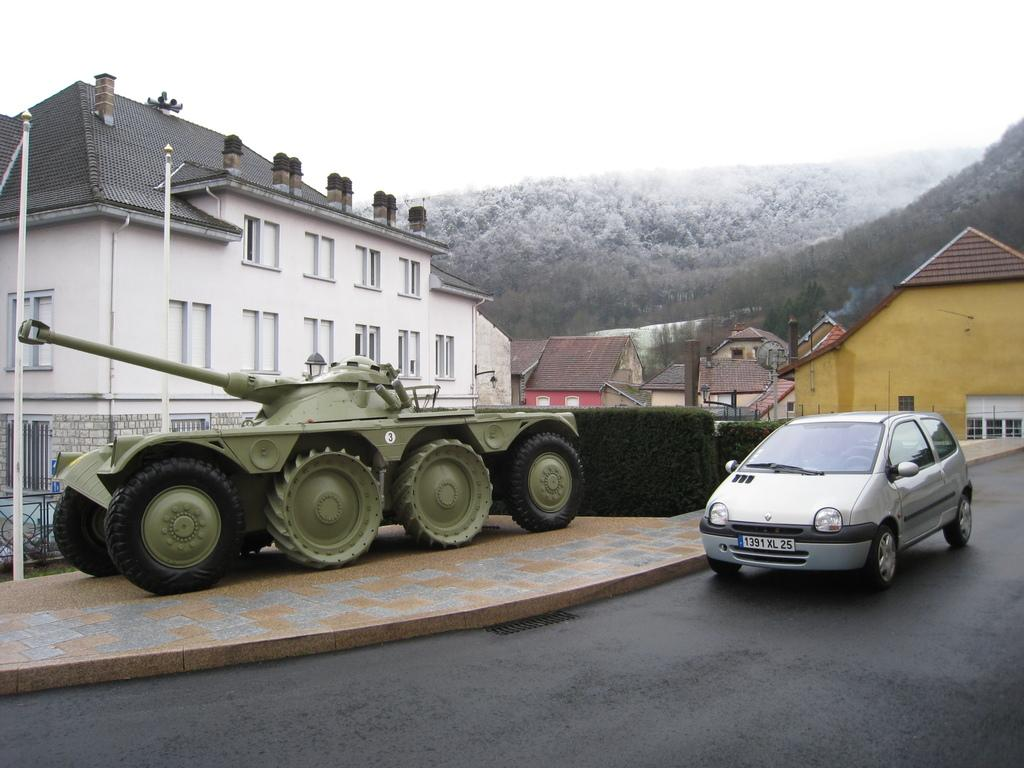What type of vehicle is in the image? There is an armored car in the image. What can be seen in the background of the image? There are buildings, hills, sheds, a hedge, and the sky visible in the background of the image. What is at the bottom of the image? There is a road at the bottom of the image. How many dogs are participating in the test in the image? There are no dogs or tests present in the image. 